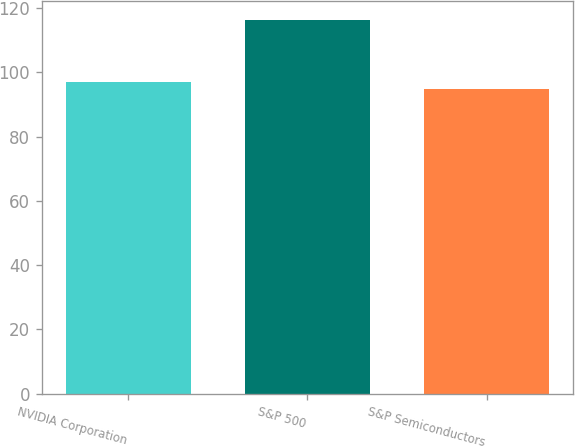<chart> <loc_0><loc_0><loc_500><loc_500><bar_chart><fcel>NVIDIA Corporation<fcel>S&P 500<fcel>S&P Semiconductors<nl><fcel>96.98<fcel>116.39<fcel>94.82<nl></chart> 